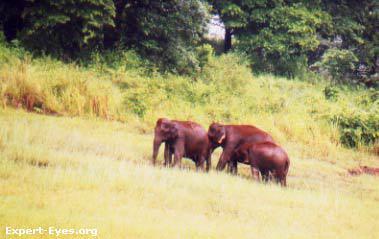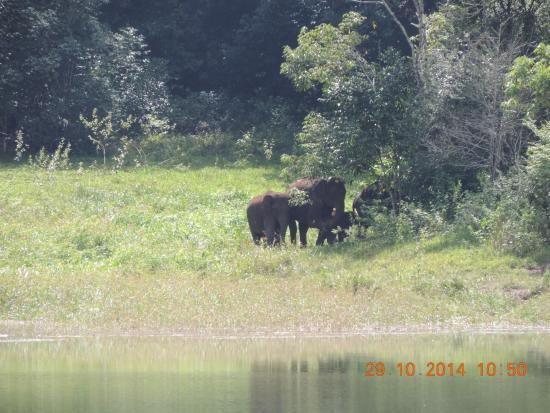The first image is the image on the left, the second image is the image on the right. For the images displayed, is the sentence "The animals in the image on the right are near watere." factually correct? Answer yes or no. Yes. The first image is the image on the left, the second image is the image on the right. For the images shown, is this caption "An image shows a group of elephants near a pool of water, but not in the water." true? Answer yes or no. Yes. 